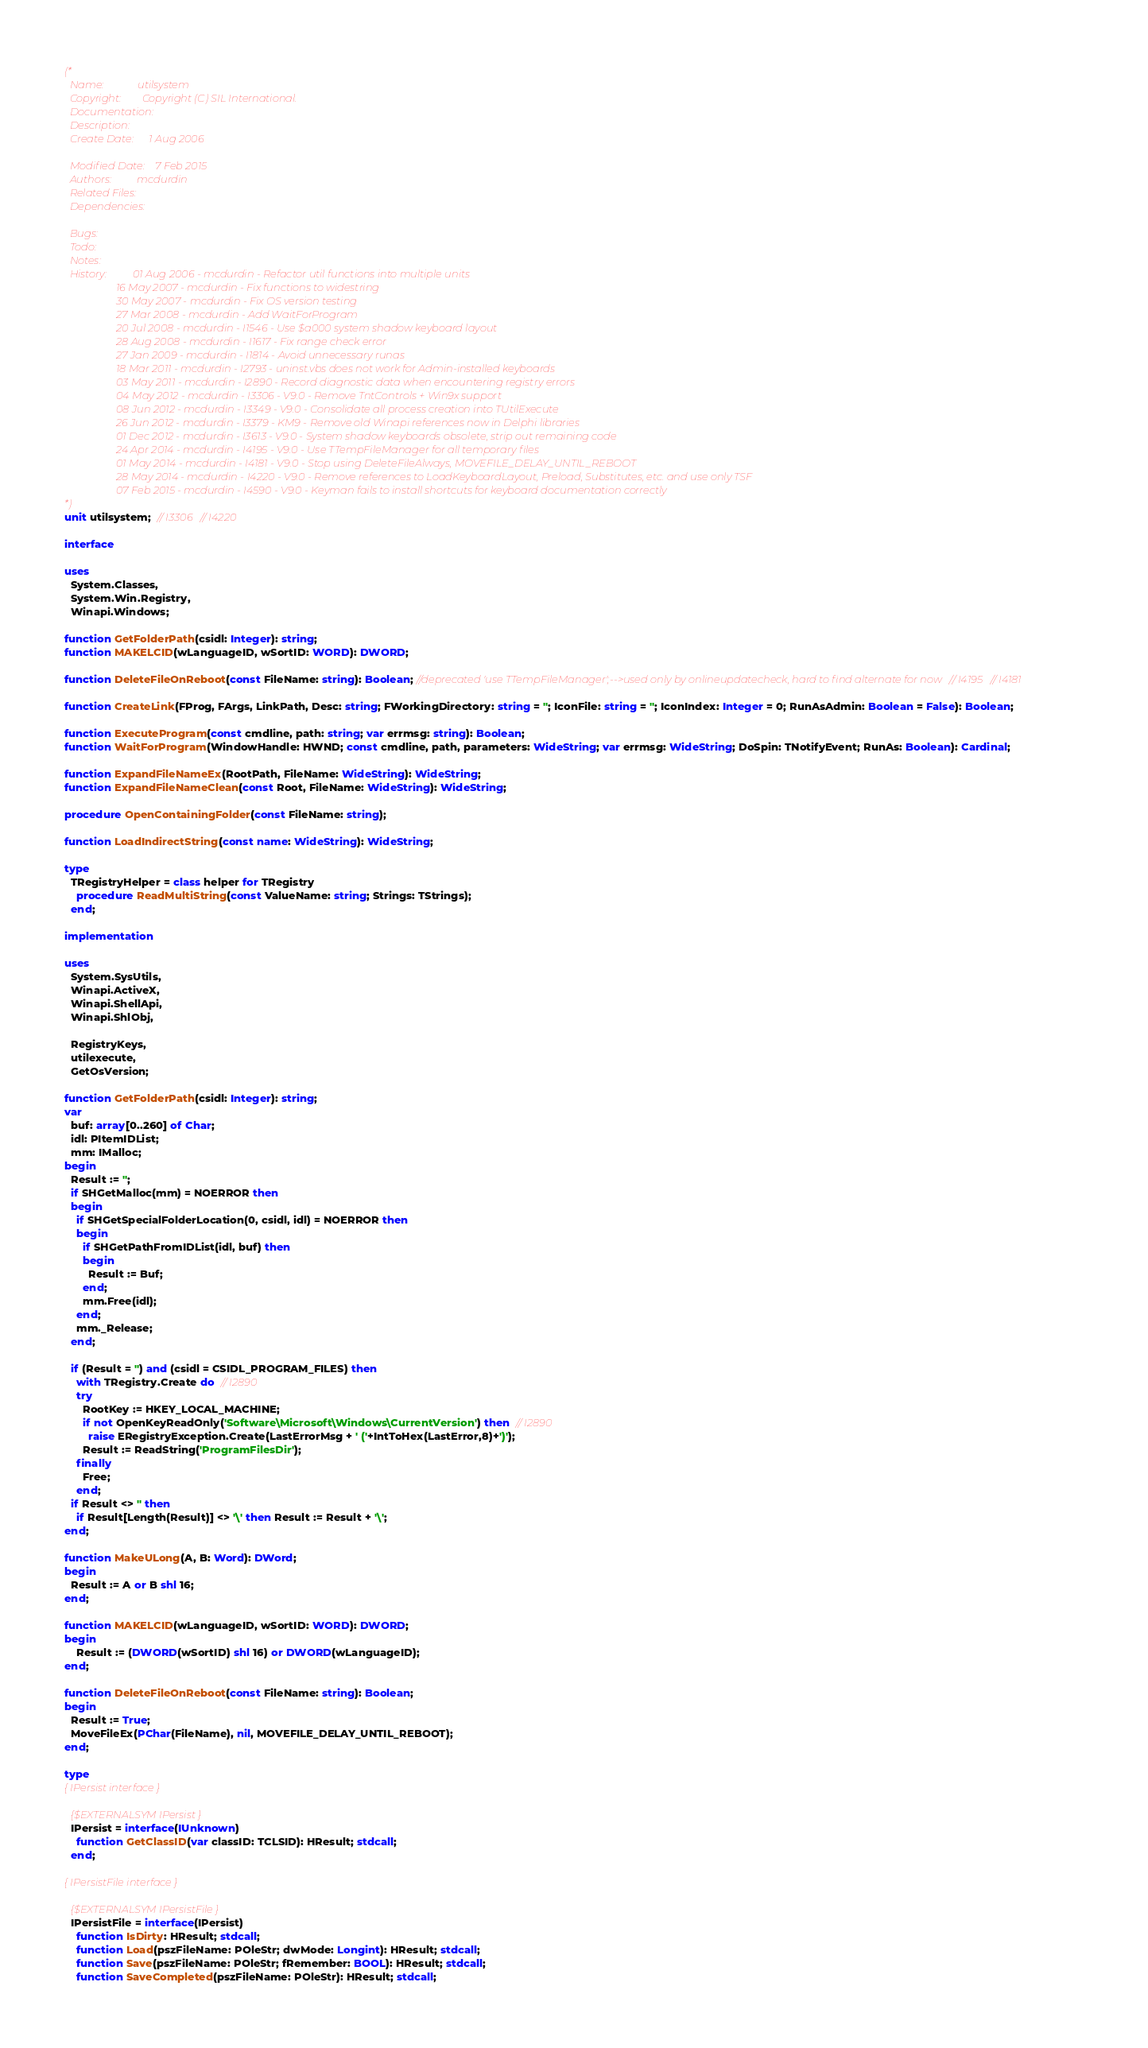<code> <loc_0><loc_0><loc_500><loc_500><_Pascal_>(*
  Name:             utilsystem
  Copyright:        Copyright (C) SIL International.
  Documentation:    
  Description:      
  Create Date:      1 Aug 2006

  Modified Date:    7 Feb 2015
  Authors:          mcdurdin
  Related Files:    
  Dependencies:     

  Bugs:             
  Todo:             
  Notes:            
  History:          01 Aug 2006 - mcdurdin - Refactor util functions into multiple units
                    16 May 2007 - mcdurdin - Fix functions to widestring
                    30 May 2007 - mcdurdin - Fix OS version testing
                    27 Mar 2008 - mcdurdin - Add WaitForProgram
                    20 Jul 2008 - mcdurdin - I1546 - Use $a000 system shadow keyboard layout
                    28 Aug 2008 - mcdurdin - I1617 - Fix range check error
                    27 Jan 2009 - mcdurdin - I1814 - Avoid unnecessary runas
                    18 Mar 2011 - mcdurdin - I2793 - uninst.vbs does not work for Admin-installed keyboards
                    03 May 2011 - mcdurdin - I2890 - Record diagnostic data when encountering registry errors
                    04 May 2012 - mcdurdin - I3306 - V9.0 - Remove TntControls + Win9x support
                    08 Jun 2012 - mcdurdin - I3349 - V9.0 - Consolidate all process creation into TUtilExecute
                    26 Jun 2012 - mcdurdin - I3379 - KM9 - Remove old Winapi references now in Delphi libraries
                    01 Dec 2012 - mcdurdin - I3613 - V9.0 - System shadow keyboards obsolete, strip out remaining code
                    24 Apr 2014 - mcdurdin - I4195 - V9.0 - Use TTempFileManager for all temporary files
                    01 May 2014 - mcdurdin - I4181 - V9.0 - Stop using DeleteFileAlways, MOVEFILE_DELAY_UNTIL_REBOOT
                    28 May 2014 - mcdurdin - I4220 - V9.0 - Remove references to LoadKeyboardLayout, Preload, Substitutes, etc. and use only TSF
                    07 Feb 2015 - mcdurdin - I4590 - V9.0 - Keyman fails to install shortcuts for keyboard documentation correctly
*)
unit utilsystem;  // I3306   // I4220

interface

uses
  System.Classes,
  System.Win.Registry,
  Winapi.Windows;

function GetFolderPath(csidl: Integer): string;
function MAKELCID(wLanguageID, wSortID: WORD): DWORD;

function DeleteFileOnReboot(const FileName: string): Boolean; //deprecated 'use TTempFileManager';-->used only by onlineupdatecheck, hard to find alternate for now   // I4195   // I4181

function CreateLink(FProg, FArgs, LinkPath, Desc: string; FWorkingDirectory: string = ''; IconFile: string = ''; IconIndex: Integer = 0; RunAsAdmin: Boolean = False): Boolean;

function ExecuteProgram(const cmdline, path: string; var errmsg: string): Boolean;
function WaitForProgram(WindowHandle: HWND; const cmdline, path, parameters: WideString; var errmsg: WideString; DoSpin: TNotifyEvent; RunAs: Boolean): Cardinal;

function ExpandFileNameEx(RootPath, FileName: WideString): WideString;
function ExpandFileNameClean(const Root, FileName: WideString): WideString;

procedure OpenContainingFolder(const FileName: string);

function LoadIndirectString(const name: WideString): WideString;

type
  TRegistryHelper = class helper for TRegistry
    procedure ReadMultiString(const ValueName: string; Strings: TStrings);
  end;

implementation

uses
  System.SysUtils,
  Winapi.ActiveX,
  Winapi.ShellApi,
  Winapi.ShlObj,

  RegistryKeys,
  utilexecute,
  GetOsVersion;

function GetFolderPath(csidl: Integer): string;
var
  buf: array[0..260] of Char;
  idl: PItemIDList;
  mm: IMalloc;
begin
  Result := '';
  if SHGetMalloc(mm) = NOERROR then
  begin
    if SHGetSpecialFolderLocation(0, csidl, idl) = NOERROR then
    begin
      if SHGetPathFromIDList(idl, buf) then
      begin
        Result := Buf;
      end;
      mm.Free(idl);
    end;
    mm._Release;
  end;

  if (Result = '') and (csidl = CSIDL_PROGRAM_FILES) then
    with TRegistry.Create do  // I2890
    try
      RootKey := HKEY_LOCAL_MACHINE;
      if not OpenKeyReadOnly('Software\Microsoft\Windows\CurrentVersion') then  // I2890
        raise ERegistryException.Create(LastErrorMsg + ' ('+IntToHex(LastError,8)+')');
      Result := ReadString('ProgramFilesDir');
    finally
      Free;
    end;
  if Result <> '' then
    if Result[Length(Result)] <> '\' then Result := Result + '\';
end;

function MakeULong(A, B: Word): DWord;
begin
  Result := A or B shl 16;
end;

function MAKELCID(wLanguageID, wSortID: WORD): DWORD;
begin
    Result := (DWORD(wSortID) shl 16) or DWORD(wLanguageID);
end;

function DeleteFileOnReboot(const FileName: string): Boolean;
begin
  Result := True;
  MoveFileEx(PChar(FileName), nil, MOVEFILE_DELAY_UNTIL_REBOOT);
end;

type
{ IPersist interface }

  {$EXTERNALSYM IPersist }
  IPersist = interface(IUnknown)
    function GetClassID(var classID: TCLSID): HResult; stdcall;
  end;

{ IPersistFile interface }

  {$EXTERNALSYM IPersistFile }
  IPersistFile = interface(IPersist)
    function IsDirty: HResult; stdcall;
    function Load(pszFileName: POleStr; dwMode: Longint): HResult; stdcall;
    function Save(pszFileName: POleStr; fRemember: BOOL): HResult; stdcall;
    function SaveCompleted(pszFileName: POleStr): HResult; stdcall;</code> 